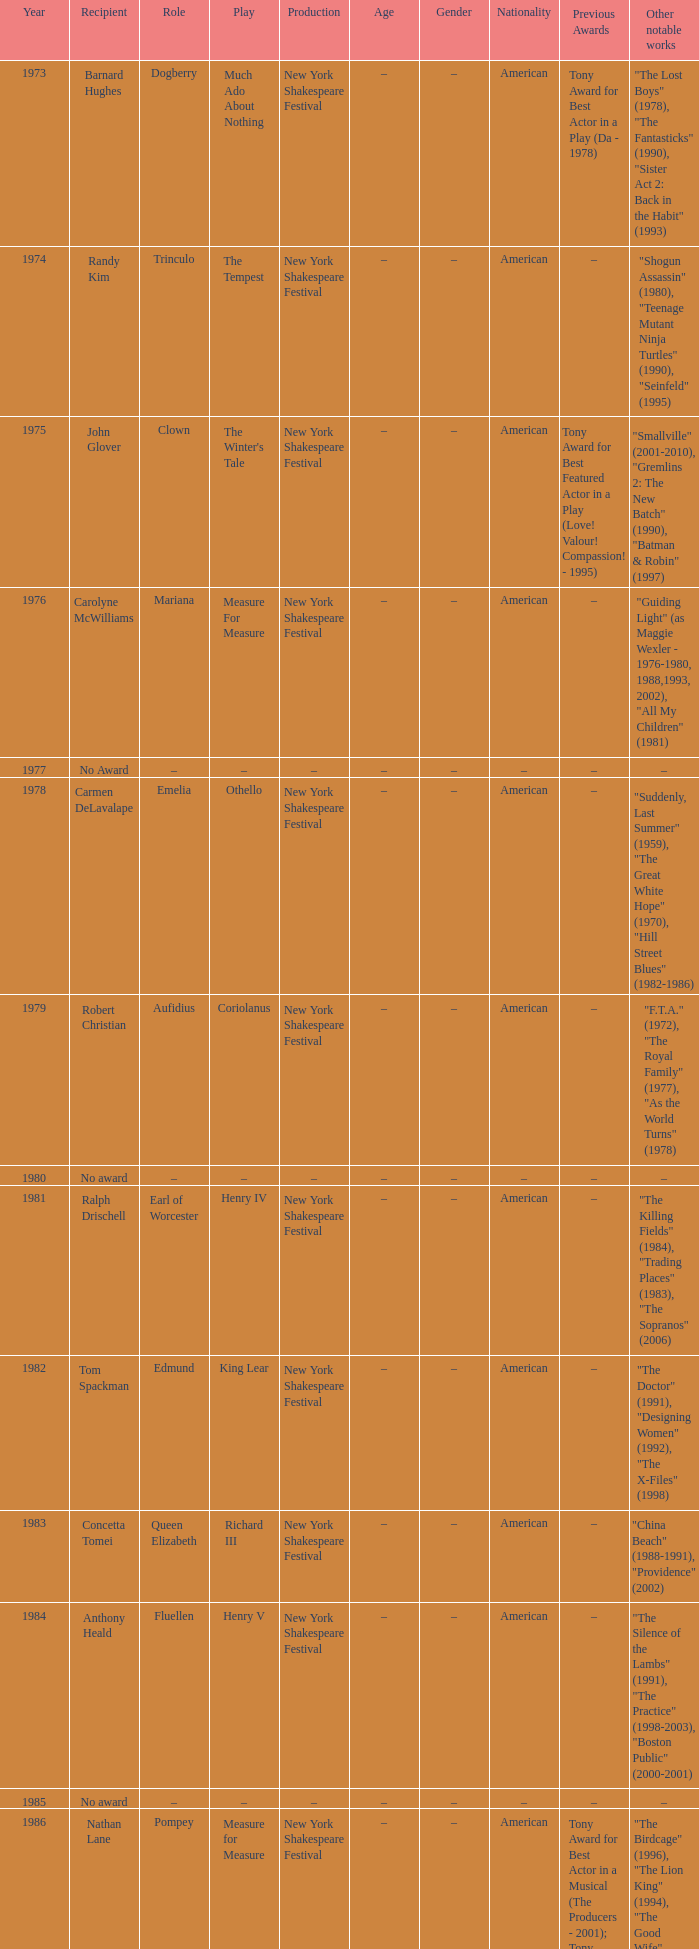Name the recipientof the year for 1976 Carolyne McWilliams. 